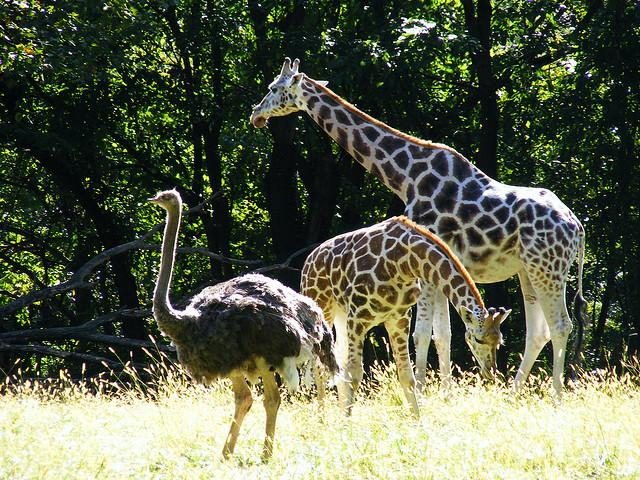How many giraffes are standing around the forest near the ostrich?

Choices:
A) three
B) four
C) two
D) five two 